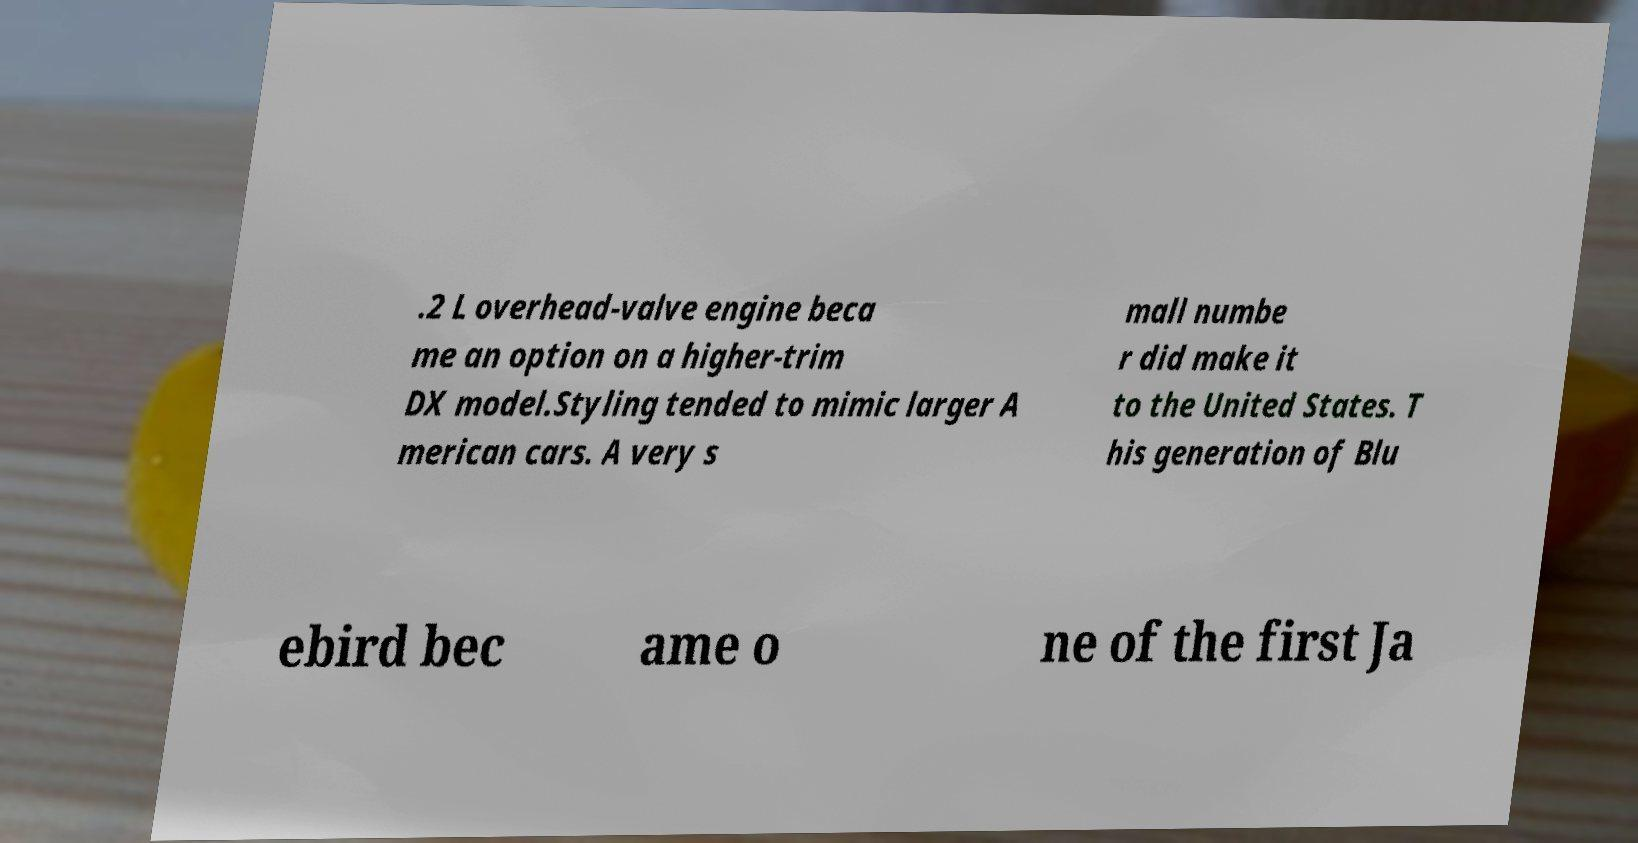Please identify and transcribe the text found in this image. .2 L overhead-valve engine beca me an option on a higher-trim DX model.Styling tended to mimic larger A merican cars. A very s mall numbe r did make it to the United States. T his generation of Blu ebird bec ame o ne of the first Ja 